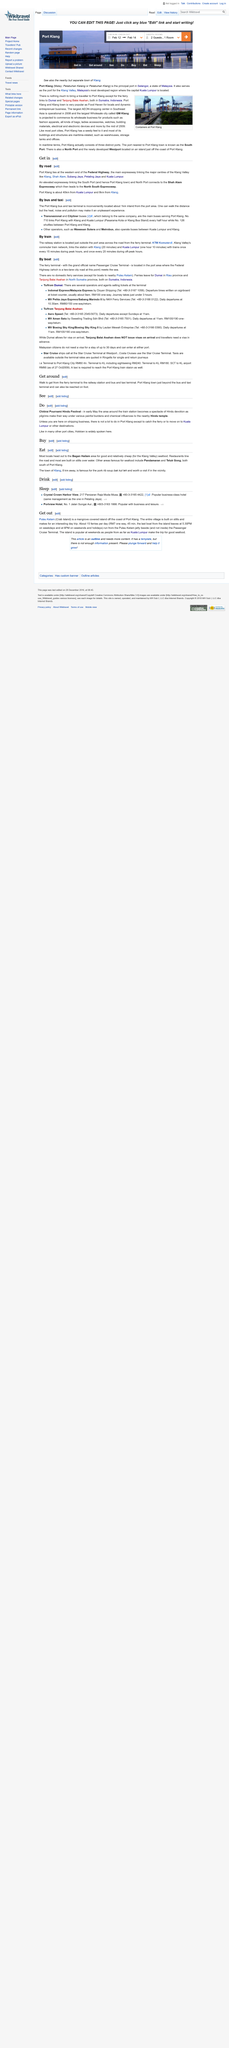Mention a couple of crucial points in this snapshot. Port Klang is 40 kilometers from Kuala Lumpur. Port Klang is 8 kilometers away from Klang. The Port Klang bus taxi terminal is located approximately 1 kilometer from the port area. 